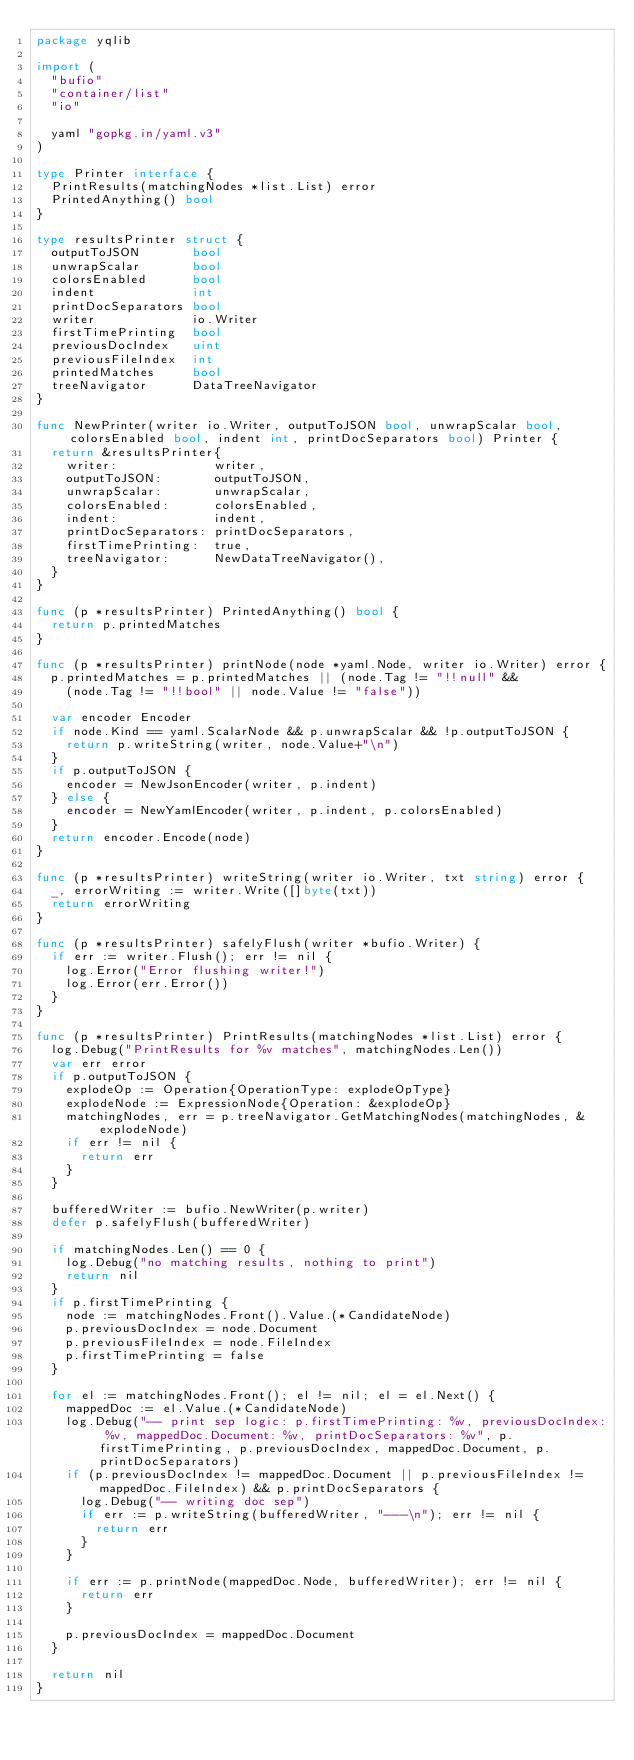Convert code to text. <code><loc_0><loc_0><loc_500><loc_500><_Go_>package yqlib

import (
	"bufio"
	"container/list"
	"io"

	yaml "gopkg.in/yaml.v3"
)

type Printer interface {
	PrintResults(matchingNodes *list.List) error
	PrintedAnything() bool
}

type resultsPrinter struct {
	outputToJSON       bool
	unwrapScalar       bool
	colorsEnabled      bool
	indent             int
	printDocSeparators bool
	writer             io.Writer
	firstTimePrinting  bool
	previousDocIndex   uint
	previousFileIndex  int
	printedMatches     bool
	treeNavigator      DataTreeNavigator
}

func NewPrinter(writer io.Writer, outputToJSON bool, unwrapScalar bool, colorsEnabled bool, indent int, printDocSeparators bool) Printer {
	return &resultsPrinter{
		writer:             writer,
		outputToJSON:       outputToJSON,
		unwrapScalar:       unwrapScalar,
		colorsEnabled:      colorsEnabled,
		indent:             indent,
		printDocSeparators: printDocSeparators,
		firstTimePrinting:  true,
		treeNavigator:      NewDataTreeNavigator(),
	}
}

func (p *resultsPrinter) PrintedAnything() bool {
	return p.printedMatches
}

func (p *resultsPrinter) printNode(node *yaml.Node, writer io.Writer) error {
	p.printedMatches = p.printedMatches || (node.Tag != "!!null" &&
		(node.Tag != "!!bool" || node.Value != "false"))

	var encoder Encoder
	if node.Kind == yaml.ScalarNode && p.unwrapScalar && !p.outputToJSON {
		return p.writeString(writer, node.Value+"\n")
	}
	if p.outputToJSON {
		encoder = NewJsonEncoder(writer, p.indent)
	} else {
		encoder = NewYamlEncoder(writer, p.indent, p.colorsEnabled)
	}
	return encoder.Encode(node)
}

func (p *resultsPrinter) writeString(writer io.Writer, txt string) error {
	_, errorWriting := writer.Write([]byte(txt))
	return errorWriting
}

func (p *resultsPrinter) safelyFlush(writer *bufio.Writer) {
	if err := writer.Flush(); err != nil {
		log.Error("Error flushing writer!")
		log.Error(err.Error())
	}
}

func (p *resultsPrinter) PrintResults(matchingNodes *list.List) error {
	log.Debug("PrintResults for %v matches", matchingNodes.Len())
	var err error
	if p.outputToJSON {
		explodeOp := Operation{OperationType: explodeOpType}
		explodeNode := ExpressionNode{Operation: &explodeOp}
		matchingNodes, err = p.treeNavigator.GetMatchingNodes(matchingNodes, &explodeNode)
		if err != nil {
			return err
		}
	}

	bufferedWriter := bufio.NewWriter(p.writer)
	defer p.safelyFlush(bufferedWriter)

	if matchingNodes.Len() == 0 {
		log.Debug("no matching results, nothing to print")
		return nil
	}
	if p.firstTimePrinting {
		node := matchingNodes.Front().Value.(*CandidateNode)
		p.previousDocIndex = node.Document
		p.previousFileIndex = node.FileIndex
		p.firstTimePrinting = false
	}

	for el := matchingNodes.Front(); el != nil; el = el.Next() {
		mappedDoc := el.Value.(*CandidateNode)
		log.Debug("-- print sep logic: p.firstTimePrinting: %v, previousDocIndex: %v, mappedDoc.Document: %v, printDocSeparators: %v", p.firstTimePrinting, p.previousDocIndex, mappedDoc.Document, p.printDocSeparators)
		if (p.previousDocIndex != mappedDoc.Document || p.previousFileIndex != mappedDoc.FileIndex) && p.printDocSeparators {
			log.Debug("-- writing doc sep")
			if err := p.writeString(bufferedWriter, "---\n"); err != nil {
				return err
			}
		}

		if err := p.printNode(mappedDoc.Node, bufferedWriter); err != nil {
			return err
		}

		p.previousDocIndex = mappedDoc.Document
	}

	return nil
}
</code> 